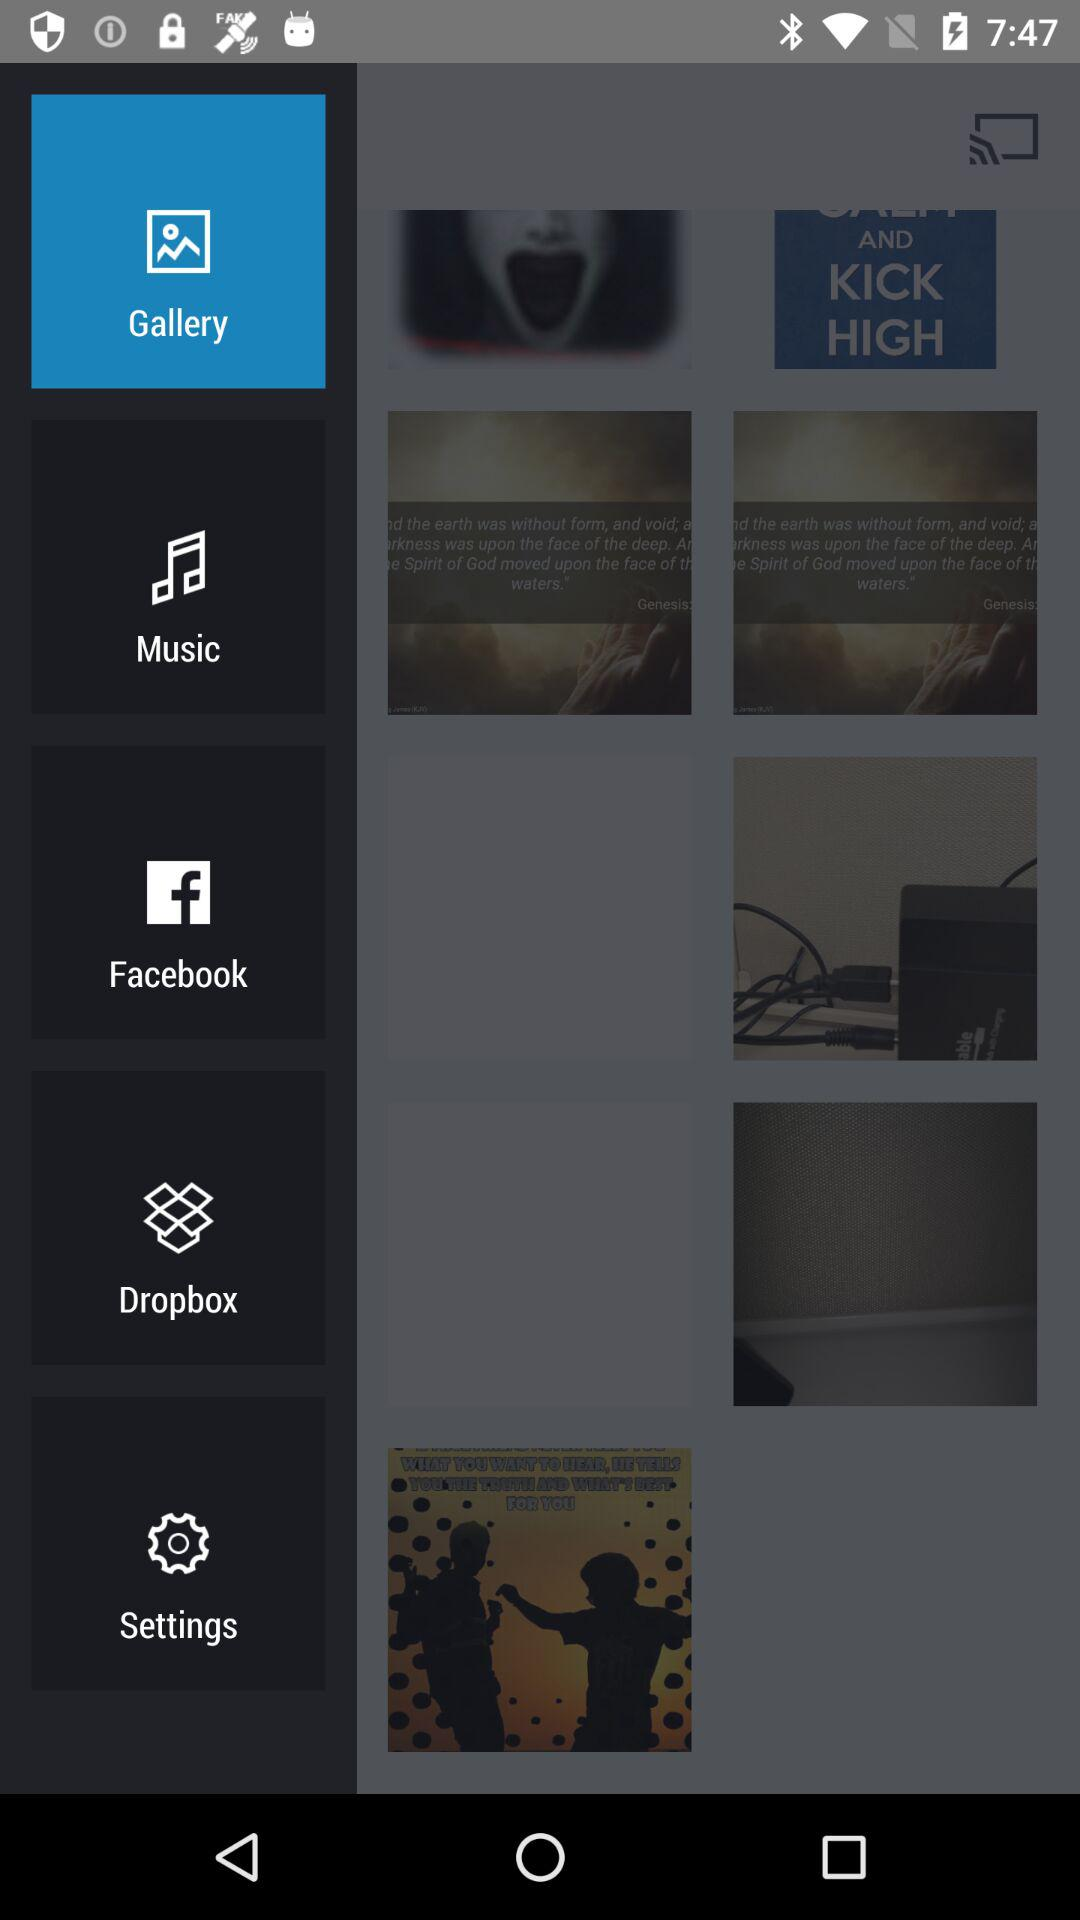How many songs are in "Music"?
When the provided information is insufficient, respond with <no answer>. <no answer> 